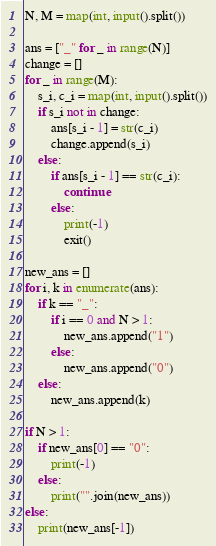Convert code to text. <code><loc_0><loc_0><loc_500><loc_500><_Python_>N, M = map(int, input().split())

ans = ["_" for _ in range(N)]
change = []
for _ in range(M):
    s_i, c_i = map(int, input().split())
    if s_i not in change:
        ans[s_i - 1] = str(c_i)
        change.append(s_i)
    else:
        if ans[s_i - 1] == str(c_i):
            continue
        else:
            print(-1)
            exit()

new_ans = []
for i, k in enumerate(ans):
    if k == "_":
        if i == 0 and N > 1:
            new_ans.append("1")
        else:
            new_ans.append("0")
    else:
        new_ans.append(k)

if N > 1:
    if new_ans[0] == "0":
        print(-1)
    else:
        print("".join(new_ans))
else:
    print(new_ans[-1])</code> 